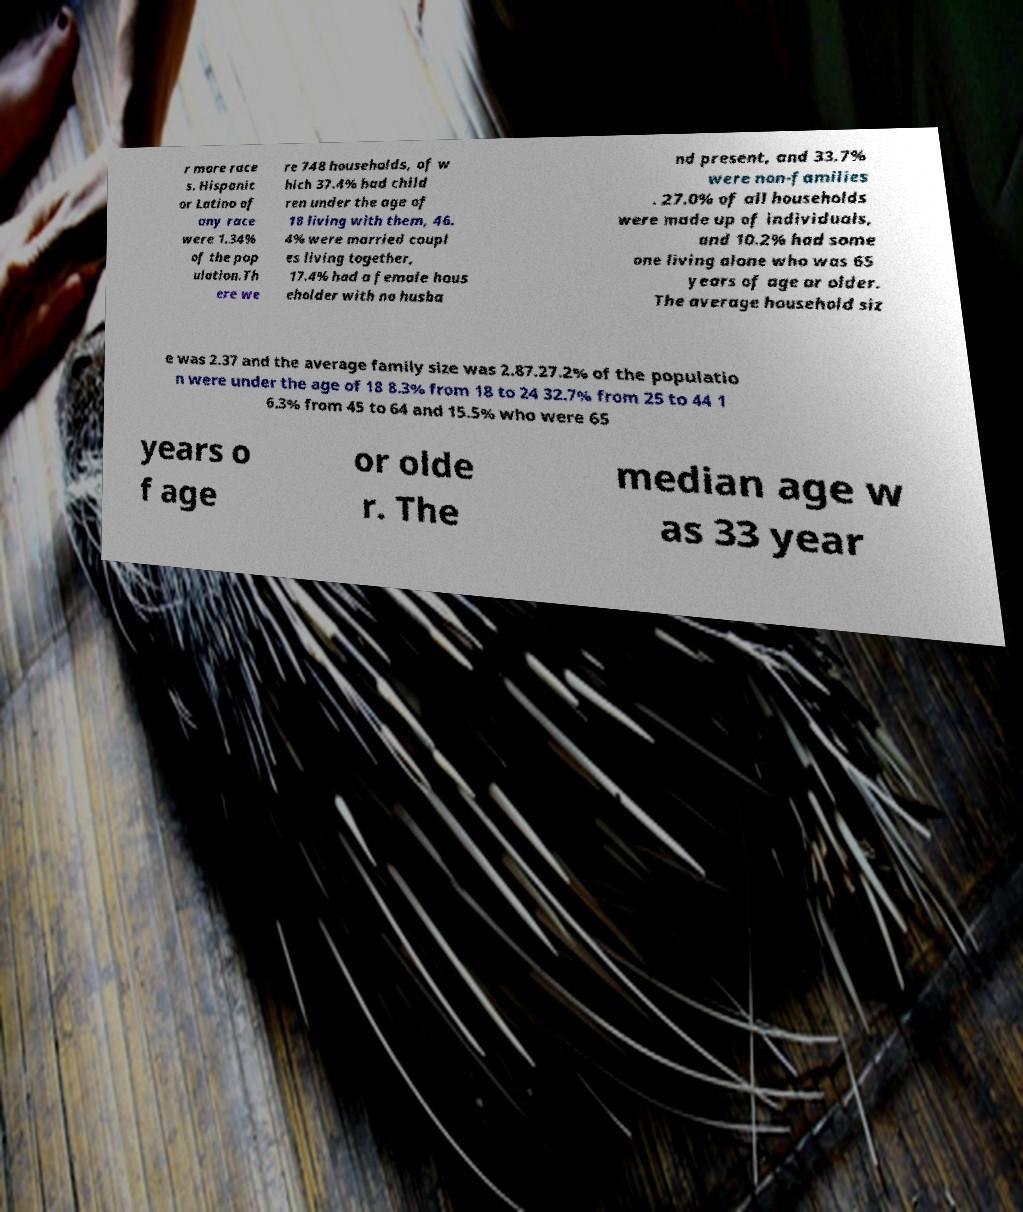Could you extract and type out the text from this image? r more race s. Hispanic or Latino of any race were 1.34% of the pop ulation.Th ere we re 748 households, of w hich 37.4% had child ren under the age of 18 living with them, 46. 4% were married coupl es living together, 17.4% had a female hous eholder with no husba nd present, and 33.7% were non-families . 27.0% of all households were made up of individuals, and 10.2% had some one living alone who was 65 years of age or older. The average household siz e was 2.37 and the average family size was 2.87.27.2% of the populatio n were under the age of 18 8.3% from 18 to 24 32.7% from 25 to 44 1 6.3% from 45 to 64 and 15.5% who were 65 years o f age or olde r. The median age w as 33 year 